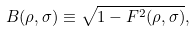Convert formula to latex. <formula><loc_0><loc_0><loc_500><loc_500>B ( \rho , \sigma ) \equiv \sqrt { 1 - F ^ { 2 } ( \rho , \sigma ) } ,</formula> 